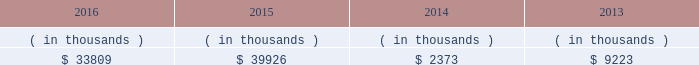System energy resources , inc .
Management 2019s financial discussion and analysis also in addition to the contractual obligations , system energy has $ 382.3 million of unrecognized tax benefits and interest net of unused tax attributes and payments for which the timing of payments beyond 12 months cannot be reasonably estimated due to uncertainties in the timing of effective settlement of tax positions .
See note 3 to the financial statements for additional information regarding unrecognized tax benefits .
In addition to routine spending to maintain operations , the planned capital investment estimate includes specific investments and initiatives such as the nuclear fleet operational excellence initiative , as discussed below in 201cnuclear matters , 201d and plant improvements .
As a wholly-owned subsidiary , system energy dividends its earnings to entergy corporation at a percentage determined monthly .
Sources of capital system energy 2019s sources to meet its capital requirements include : 2022 internally generated funds ; 2022 cash on hand ; 2022 debt issuances ; and 2022 bank financing under new or existing facilities .
System energy may refinance , redeem , or otherwise retire debt prior to maturity , to the extent market conditions and interest and dividend rates are favorable .
All debt and common stock issuances by system energy require prior regulatory approval .
Debt issuances are also subject to issuance tests set forth in its bond indentures and other agreements .
System energy has sufficient capacity under these tests to meet its foreseeable capital needs .
System energy 2019s receivables from the money pool were as follows as of december 31 for each of the following years. .
See note 4 to the financial statements for a description of the money pool .
The system energy nuclear fuel company variable interest entity has a credit facility in the amount of $ 120 million scheduled to expire in may 2019 .
As of december 31 , 2016 , $ 66.9 million in letters of credit were outstanding under the credit facility to support a like amount of commercial paper issued by the system energy nuclear fuel company variable interest entity .
See note 4 to the financial statements for additional discussion of the variable interest entity credit facility .
System energy obtained authorizations from the ferc through october 2017 for the following : 2022 short-term borrowings not to exceed an aggregate amount of $ 200 million at any time outstanding ; 2022 long-term borrowings and security issuances ; and 2022 long-term borrowings by its nuclear fuel company variable interest entity .
See note 4 to the financial statements for further discussion of system energy 2019s short-term borrowing limits. .
What is the net change in system energy 2019s receivables from the money pool from 2014 to 2015? 
Computations: (39926 - 2373)
Answer: 37553.0. 